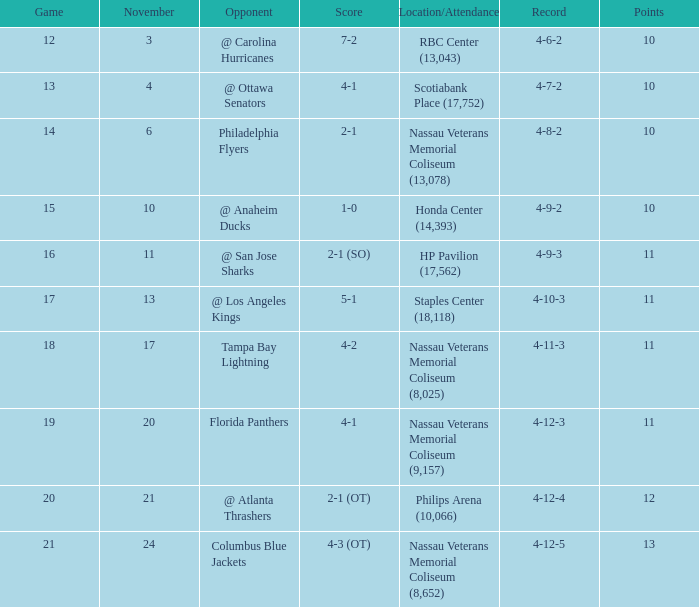What is the highest entry in November for the game 20? 21.0. 